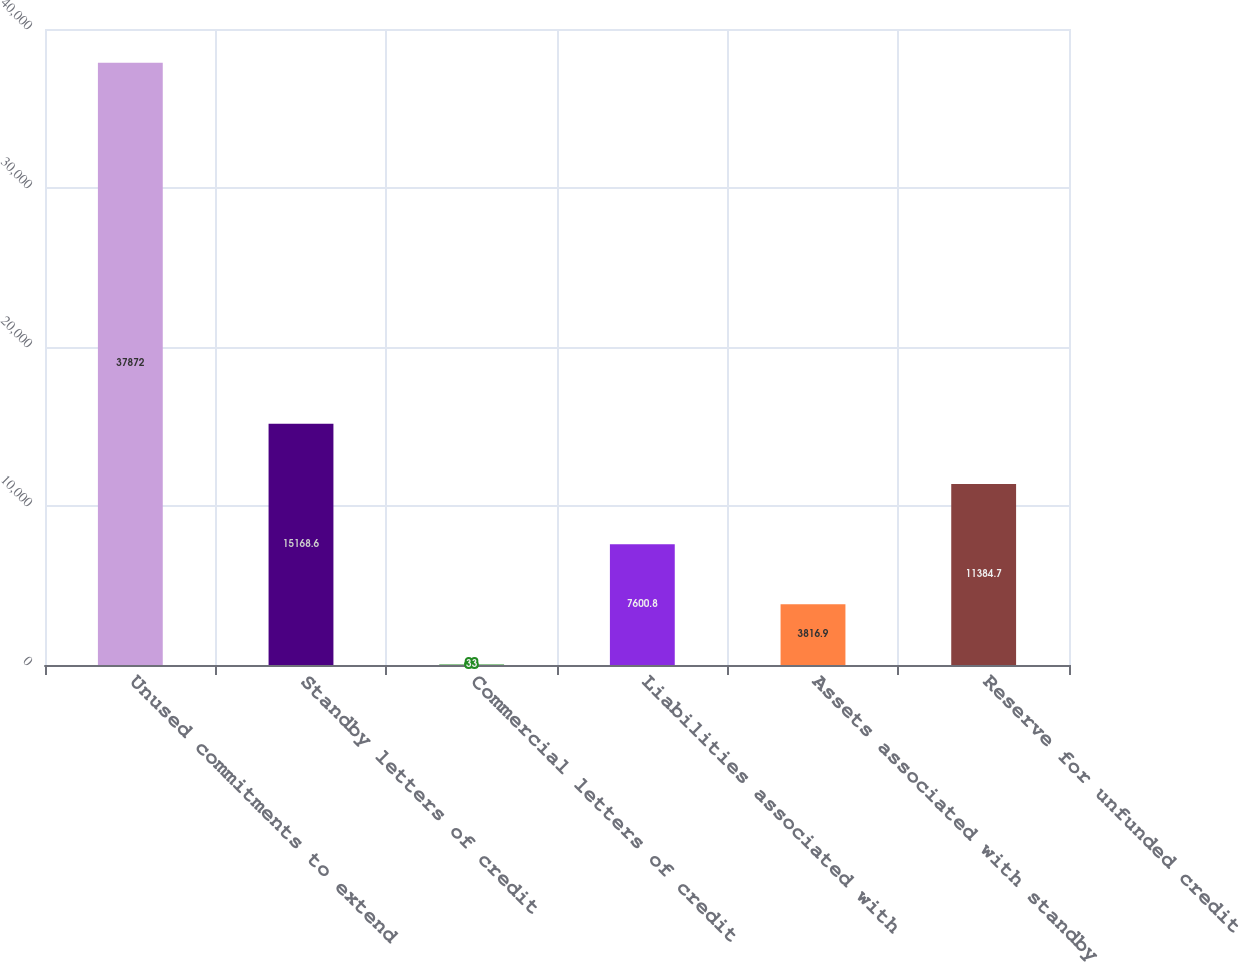Convert chart. <chart><loc_0><loc_0><loc_500><loc_500><bar_chart><fcel>Unused commitments to extend<fcel>Standby letters of credit<fcel>Commercial letters of credit<fcel>Liabilities associated with<fcel>Assets associated with standby<fcel>Reserve for unfunded credit<nl><fcel>37872<fcel>15168.6<fcel>33<fcel>7600.8<fcel>3816.9<fcel>11384.7<nl></chart> 